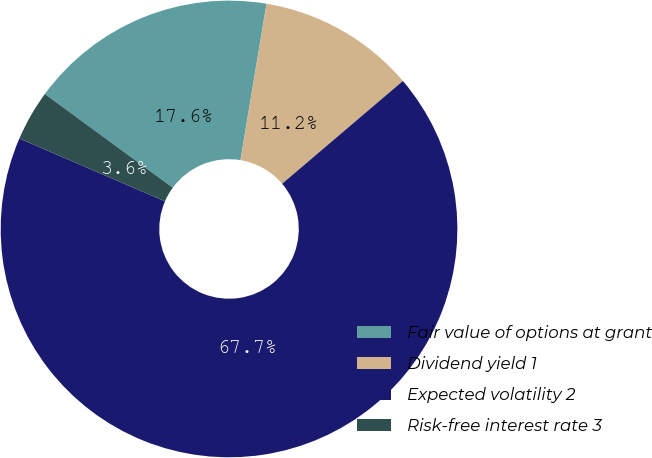<chart> <loc_0><loc_0><loc_500><loc_500><pie_chart><fcel>Fair value of options at grant<fcel>Dividend yield 1<fcel>Expected volatility 2<fcel>Risk-free interest rate 3<nl><fcel>17.56%<fcel>11.15%<fcel>67.7%<fcel>3.58%<nl></chart> 